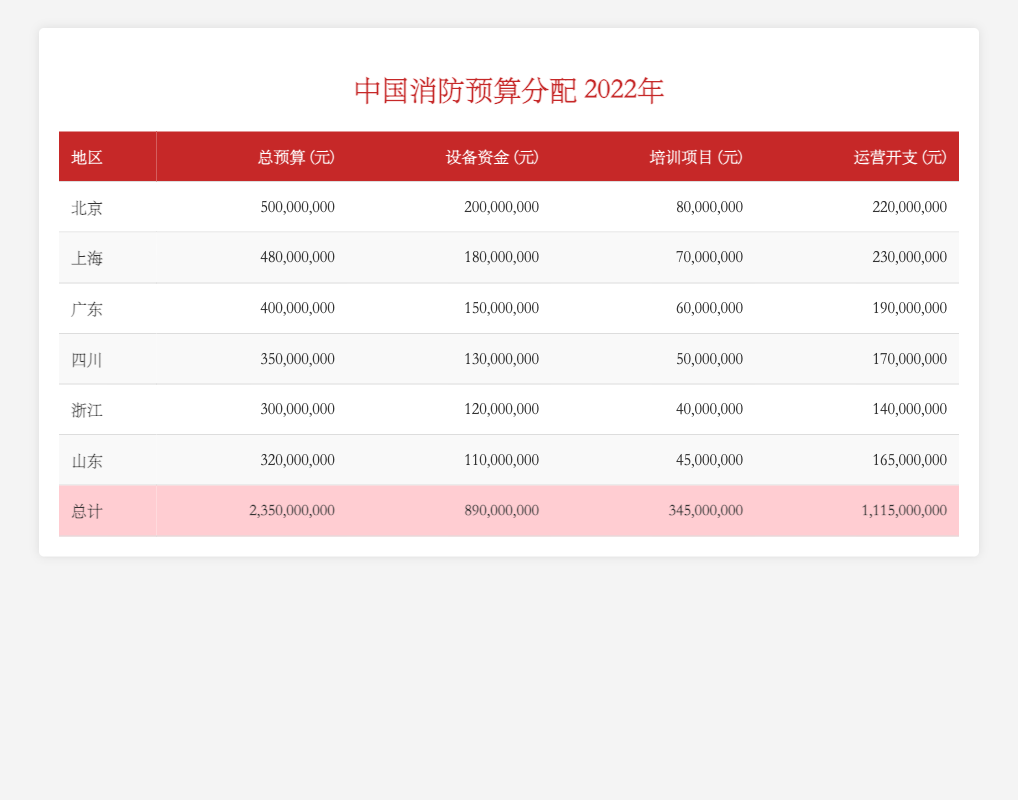What is the total budget for the Zhejiang firefighting department in 2022? The total budget for the Zhejiang firefighting department is directly indicated in the table. From the row corresponding to Zhejiang, the total budget is listed as 300,000,000 yuan.
Answer: 300,000,000 How much budget did the Sichuan firefighting department allocate for training programs? The training program funding for Sichuan is found in the corresponding row in the table. The amount is listed as 50,000,000 yuan.
Answer: 50,000,000 Which region has the highest operational expenses, and what is the amount? To find this, I will compare the operational expenses across all regions. Looking at the values, Beijing has 220,000,000 yuan, Shanghai has 230,000,000 yuan, and upon comparison, Shanghai has the highest operational expense of 230,000,000 yuan.
Answer: Shanghai, 230,000,000 What is the total funding for equipment across all regions? To calculate the total equipment funding, I will sum up the equipment funding for each region: 200,000,000 (Beijing) + 180,000,000 (Shanghai) + 150,000,000 (Guangdong) + 130,000,000 (Sichuan) + 120,000,000 (Zhejiang) + 110,000,000 (Shandong) = 890,000,000 yuan.
Answer: 890,000,000 Is the total budget for Guangdong more than the combined training programs funding for Shanghai and Zhejiang? The training funding for Shanghai is 70,000,000 yuan and for Zhejiang is 40,000,000 yuan. Summing these gives 110,000,000 yuan. Guangdong's total budget is 400,000,000 which is indeed more than 110,000,000 yuan.
Answer: Yes How does the operational expense of Shandong compare to its total budget? The total budget for Shandong is 320,000,000 yuan and its operational expenses are 165,000,000 yuan. To determine if operational expenses are less than total budget, I compare the two figures, and 165,000,000 is less than 320,000,000.
Answer: Less than What is the average equipment funding for the firefighting departments in the listed regions? To find the average, I sum the equipment funding for all regions: 200,000,000 + 180,000,000 + 150,000,000 + 130,000,000 + 120,000,000 + 110,000,000 = 890,000,000. Then, dividing by the number of regions (6): 890,000,000 / 6 = 148,333,333.33. Rounding gives about 148,333,333.
Answer: 148,333,333 What percentage of the total budget for Beijing is allocated to equipment funding? To calculate the percentage of equipment funding in the total budget, I will use the formula: (Equipment Funding / Total Budget) * 100. Beijing has 200,000,000 in equipment funding out of a 500,000,000 total budget. So, (200,000,000 / 500,000,000) * 100 = 40 percent.
Answer: 40 percent Which region had a total budget that is less than 400 million yuan? Looking at the total budget values for each region, Sichuan (350,000,000), Zhejiang (300,000,000), and Shandong (320,000,000) are all less than 400 million yuan.
Answer: Sichuan, Zhejiang, Shandong 